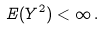<formula> <loc_0><loc_0><loc_500><loc_500>E ( Y ^ { 2 } ) < \infty \, .</formula> 